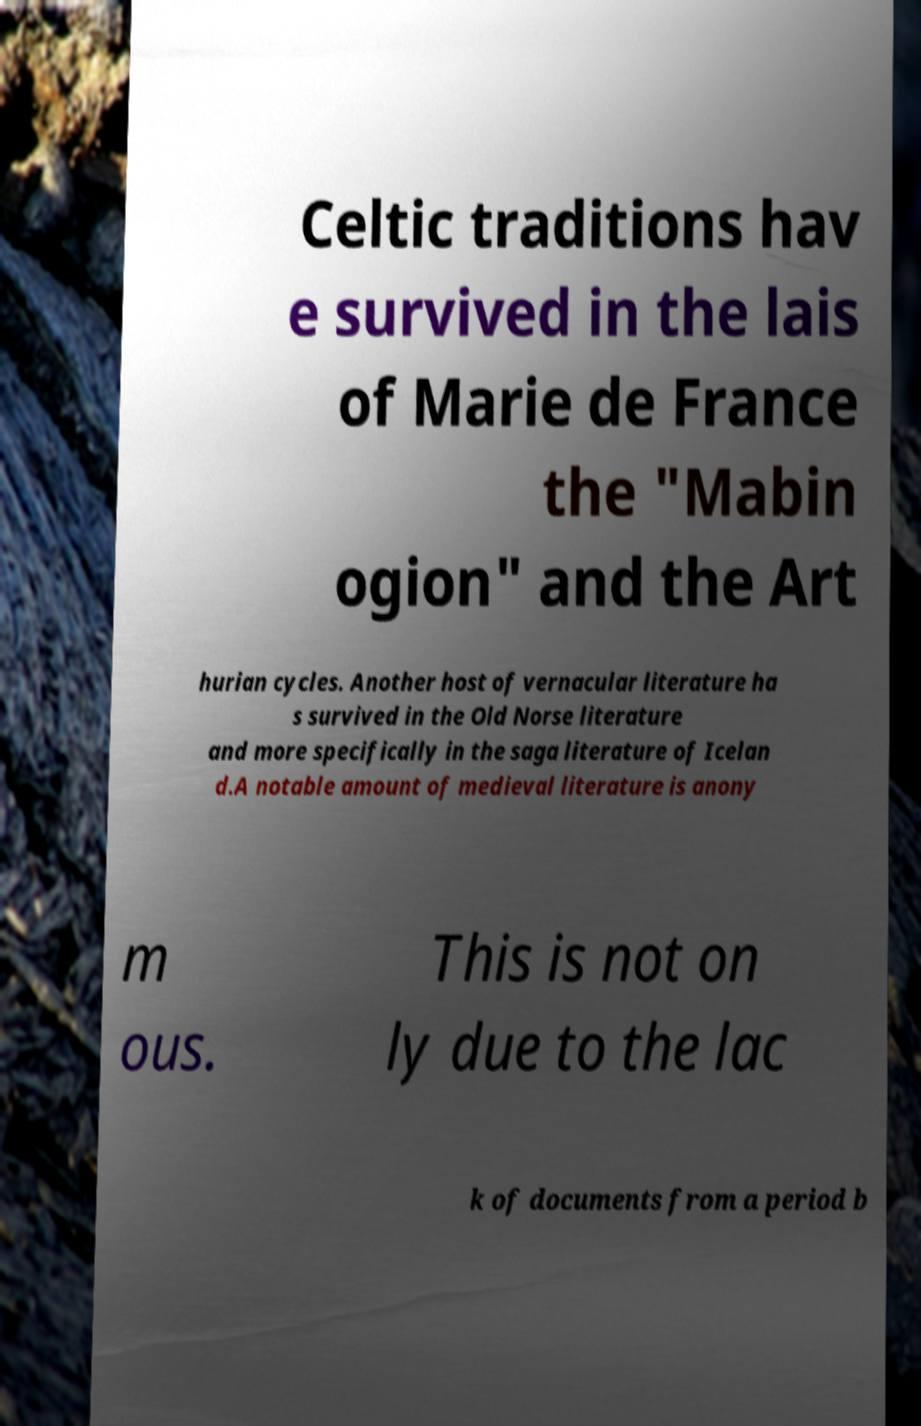There's text embedded in this image that I need extracted. Can you transcribe it verbatim? Celtic traditions hav e survived in the lais of Marie de France the "Mabin ogion" and the Art hurian cycles. Another host of vernacular literature ha s survived in the Old Norse literature and more specifically in the saga literature of Icelan d.A notable amount of medieval literature is anony m ous. This is not on ly due to the lac k of documents from a period b 